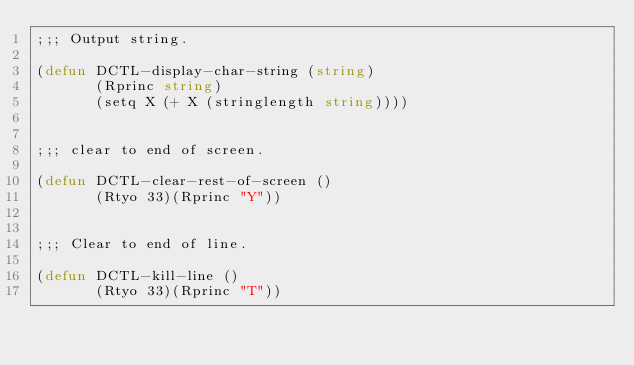<code> <loc_0><loc_0><loc_500><loc_500><_Lisp_>;;; Output string.

(defun DCTL-display-char-string (string)
       (Rprinc string)
       (setq X (+ X (stringlength string))))


;;; clear to end of screen.

(defun DCTL-clear-rest-of-screen ()
       (Rtyo 33)(Rprinc "Y"))


;;; Clear to end of line.

(defun DCTL-kill-line ()
       (Rtyo 33)(Rprinc "T"))


</code> 